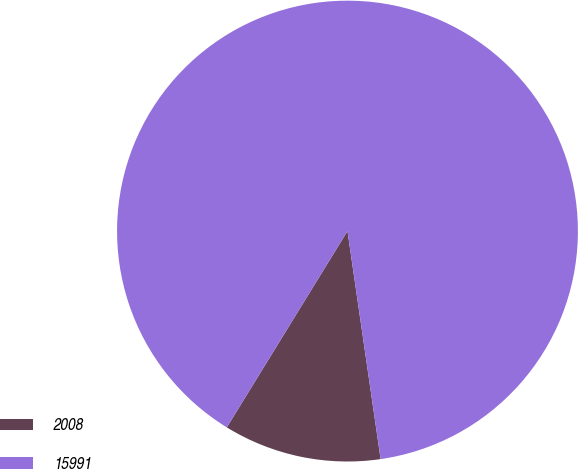<chart> <loc_0><loc_0><loc_500><loc_500><pie_chart><fcel>2008<fcel>15991<nl><fcel>11.07%<fcel>88.93%<nl></chart> 